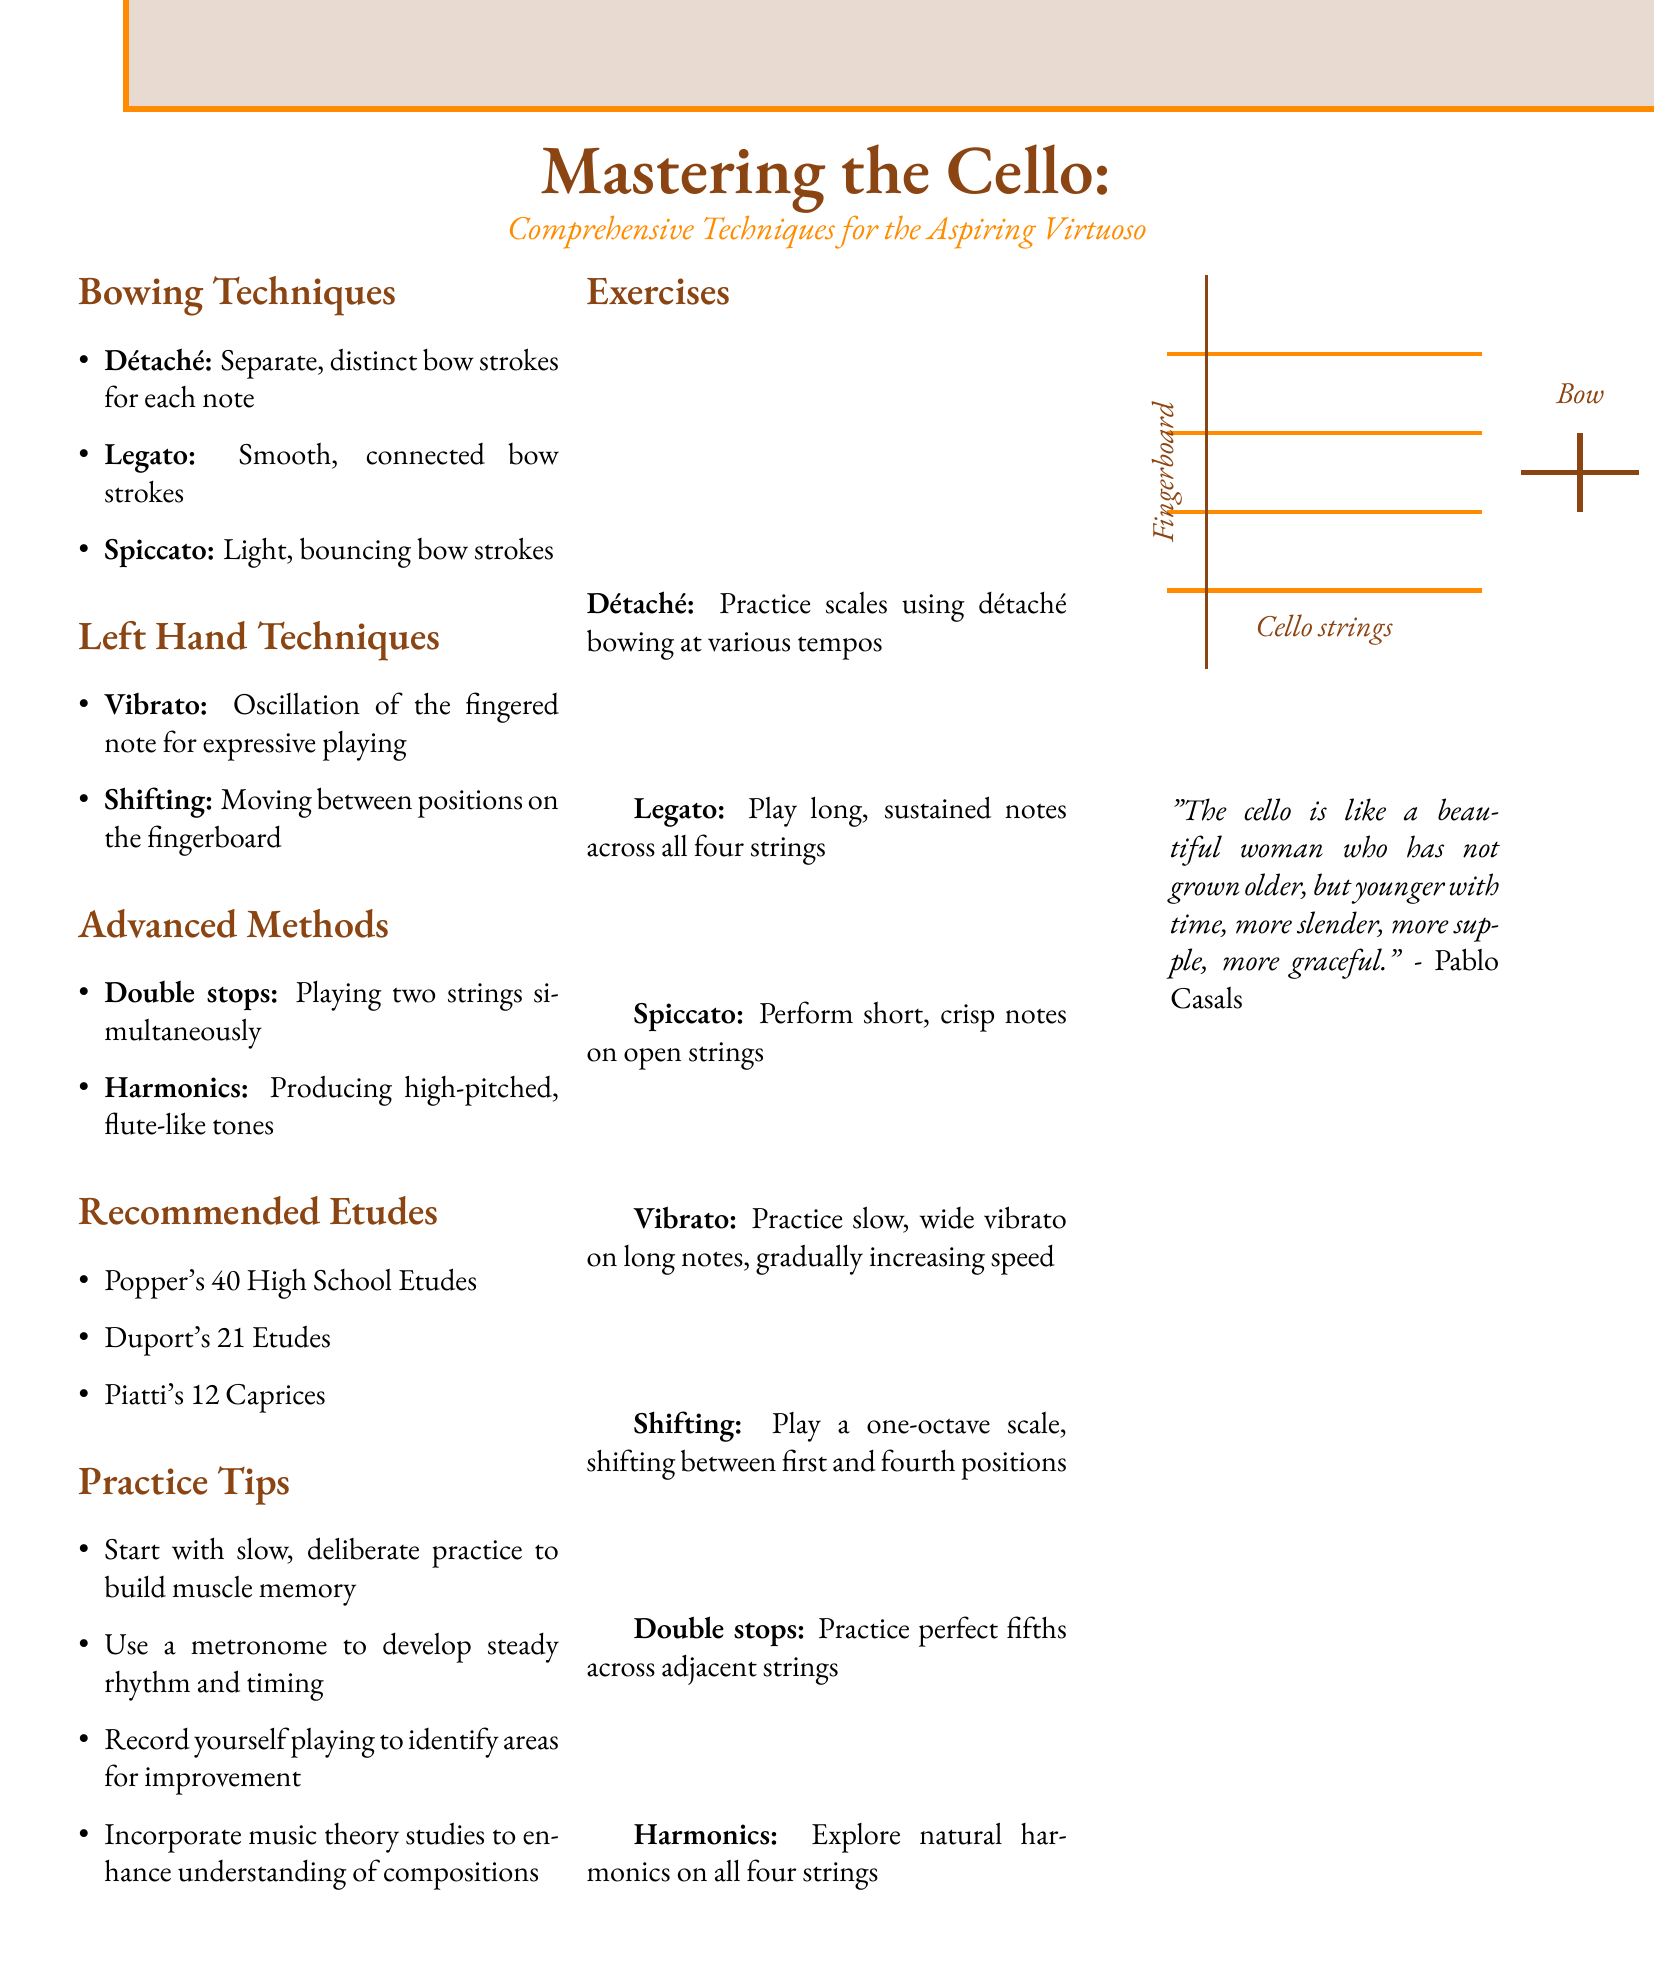what are three bowing techniques mentioned? The document lists several bowing techniques under the Bowing Techniques section, which includes "Détaché," "Legato," and "Spiccato."
Answer: Détaché, Legato, Spiccato what is the name of the recommended etudes? The document provides a list of recommended etudes for cello practice, specifically "Popper's 40 High School Etudes," "Duport's 21 Etudes," and "Piatti's 12 Caprices."
Answer: Popper's 40 High School Etudes, Duport's 21 Etudes, Piatti's 12 Caprices how many advanced methods are listed? The document includes an Advanced Methods section that specifies two techniques, which are "Double stops" and "Harmonics."
Answer: 2 what is one practice tip mentioned? The document suggests several practice tips in the Practice Tips section, such as "Start with slow, deliberate practice to build muscle memory."
Answer: Start with slow, deliberate practice to build muscle memory what type of string technique is defined as simultaneous? The Advanced Methods section defines a technique that involves playing two strings at the same time, specified as "Double stops."
Answer: Double stops what do you practice for legato? The Exercises section suggests practicing long, sustained notes across all four strings to develop legato bowing style.
Answer: Long, sustained notes across all four strings what is a characteristic of vibrato mentioned? The document describes vibrato as "oscillation of the fingered note for expressive playing" in the Left Hand Techniques section.
Answer: Oscillation of the fingered note for expressive playing which string technique is related to position transitions? The Left Hand Techniques states that "Shifting" relates to moving between positions on the fingerboard.
Answer: Shifting how should one start practicing scales using détaché? The Exercises section advises to practice scales using détaché bowing at various tempos, implying the need for varying speeds in practice.
Answer: Using various tempos 